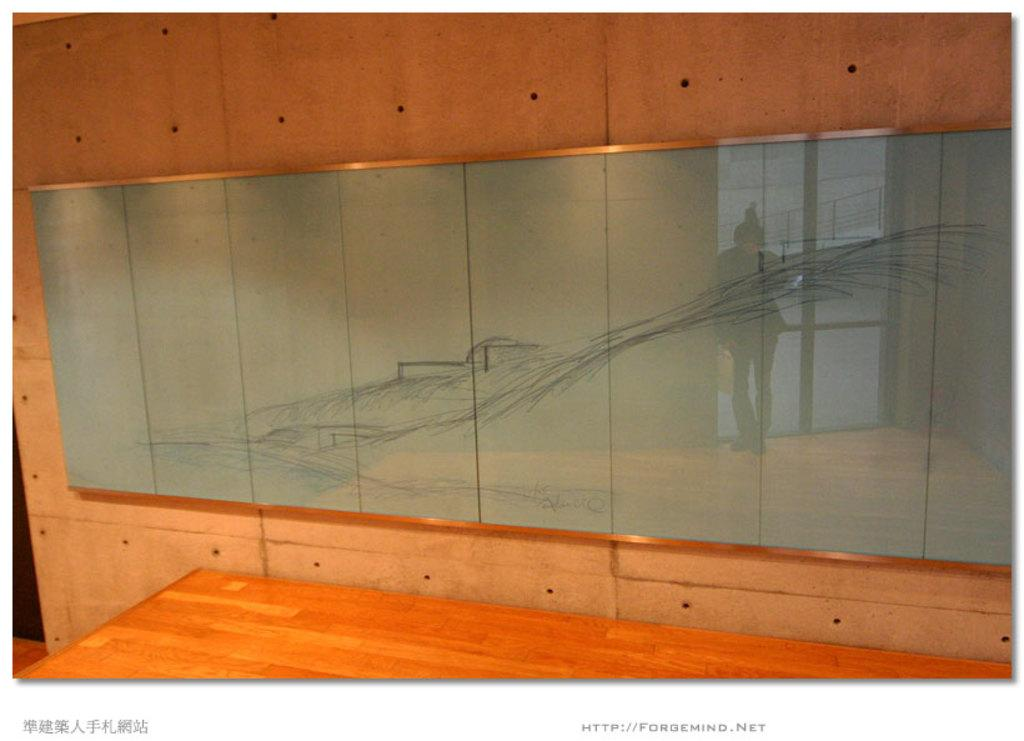What type of furniture is present in the image? There is a table in the image. What is on the wall in the image? There is a glass board on the wall. What can be seen in the reflection of the glass board? The glass board reflects a person standing on the floor. What type of barrier is visible in the image? There is a fence visible in the image. What type of access points are visible in the image? There are doors visible in the image. What type of bean is growing on the fence in the image? There are no beans present in the image, and the fence is not associated with any plant growth. What type of box is being used to store the doors in the image? There are no boxes present in the image, and the doors are not stored in any container. 